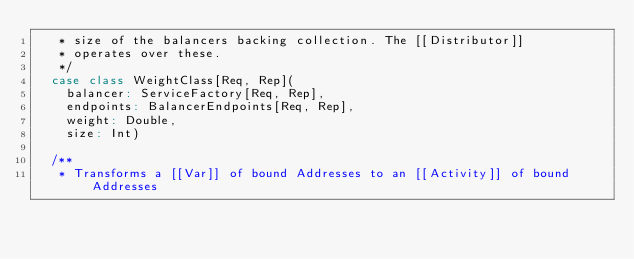Convert code to text. <code><loc_0><loc_0><loc_500><loc_500><_Scala_>   * size of the balancers backing collection. The [[Distributor]]
   * operates over these.
   */
  case class WeightClass[Req, Rep](
    balancer: ServiceFactory[Req, Rep],
    endpoints: BalancerEndpoints[Req, Rep],
    weight: Double,
    size: Int)

  /**
   * Transforms a [[Var]] of bound Addresses to an [[Activity]] of bound Addresses</code> 